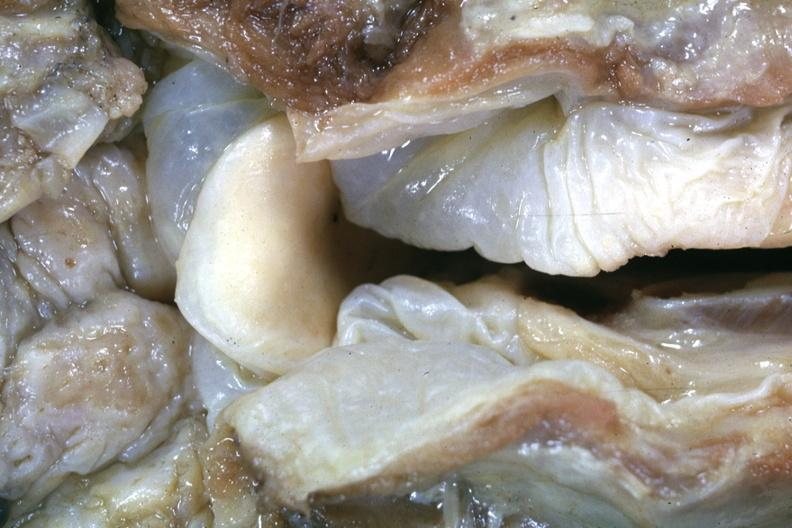how is this a very good example of a lesion seldom seen at slide?
Answer the question using a single word or phrase. Autopsy 